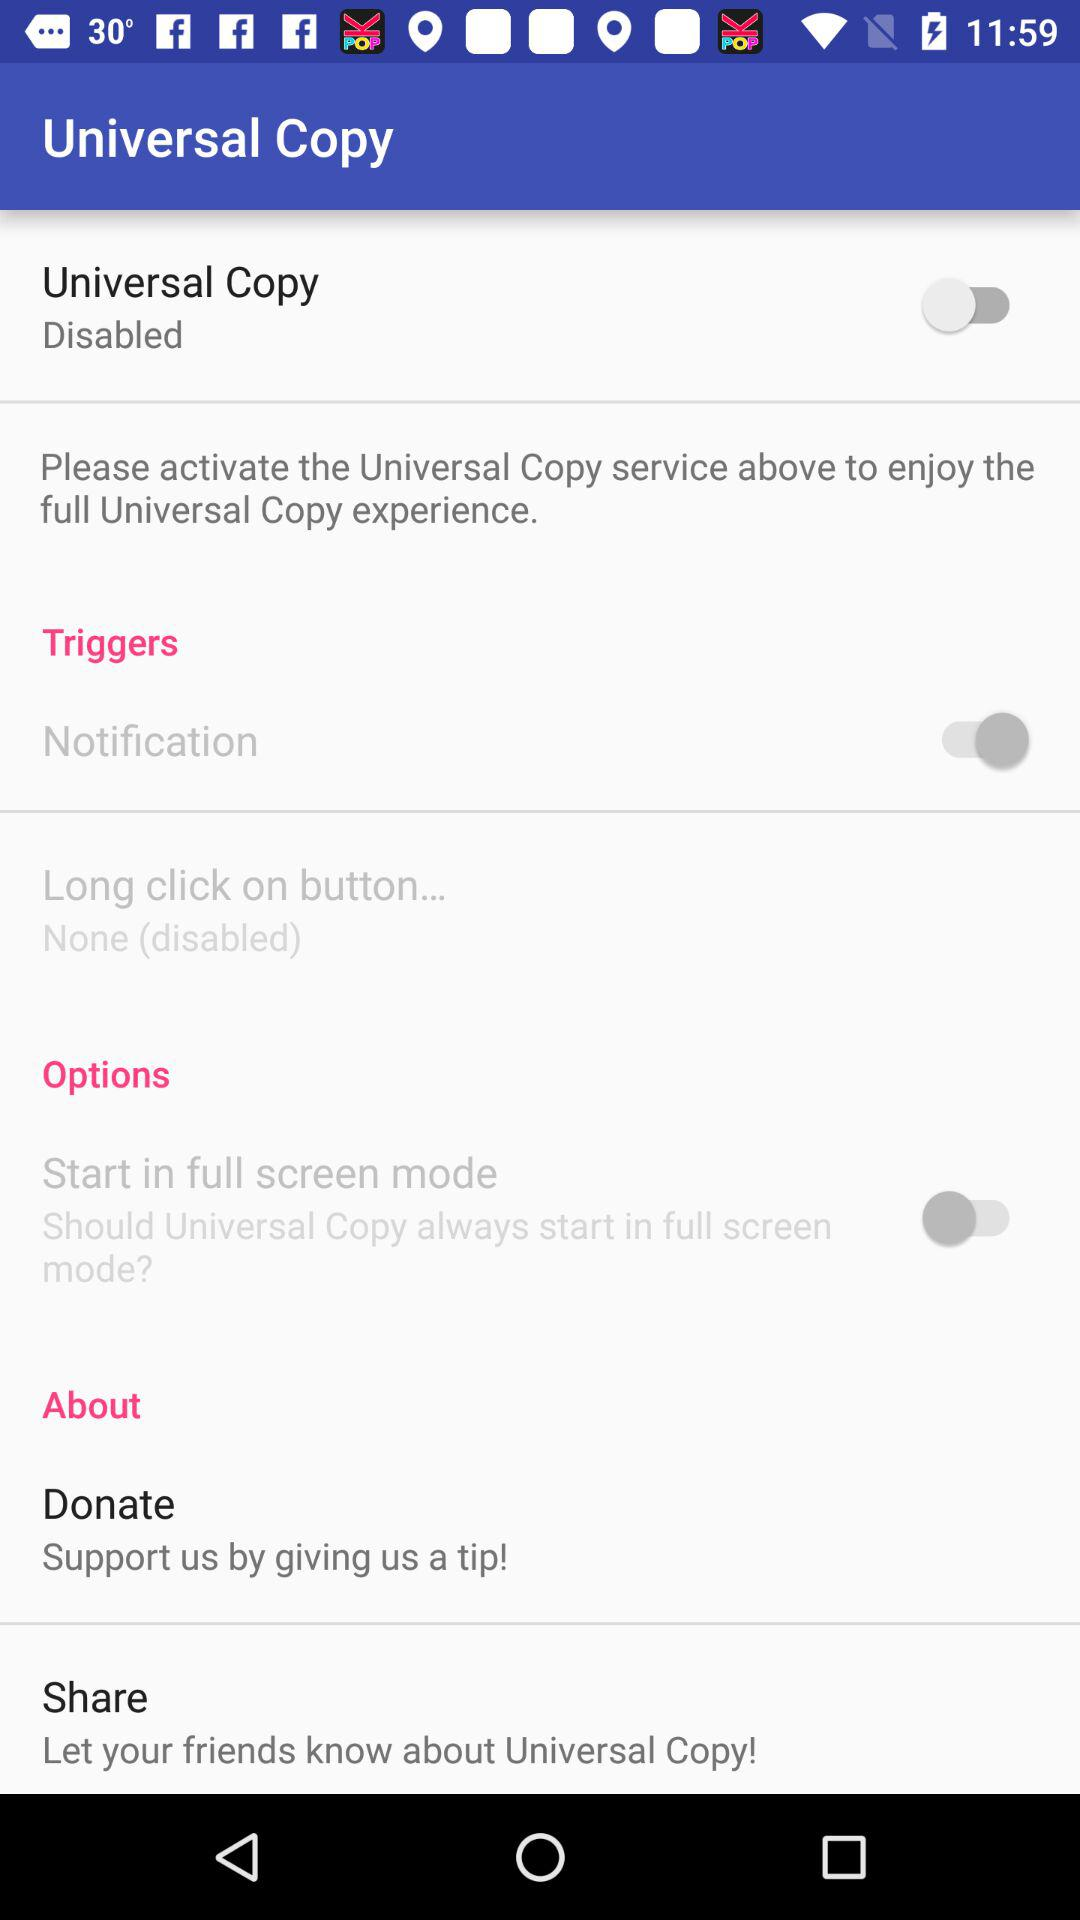What is the status of the "Universal Copy"? The status of the "Universal Copy" is "off". 